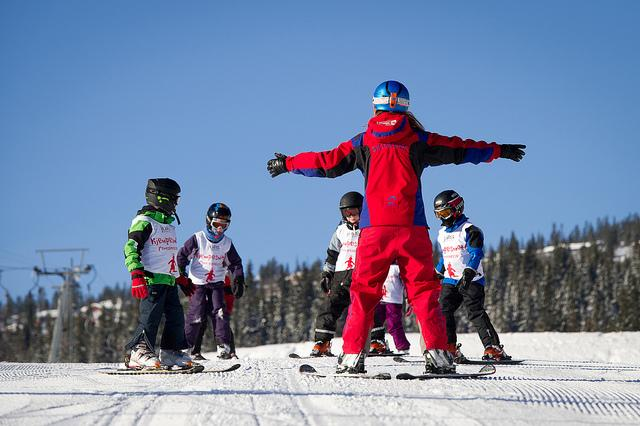What does the person in red provide? instruction 